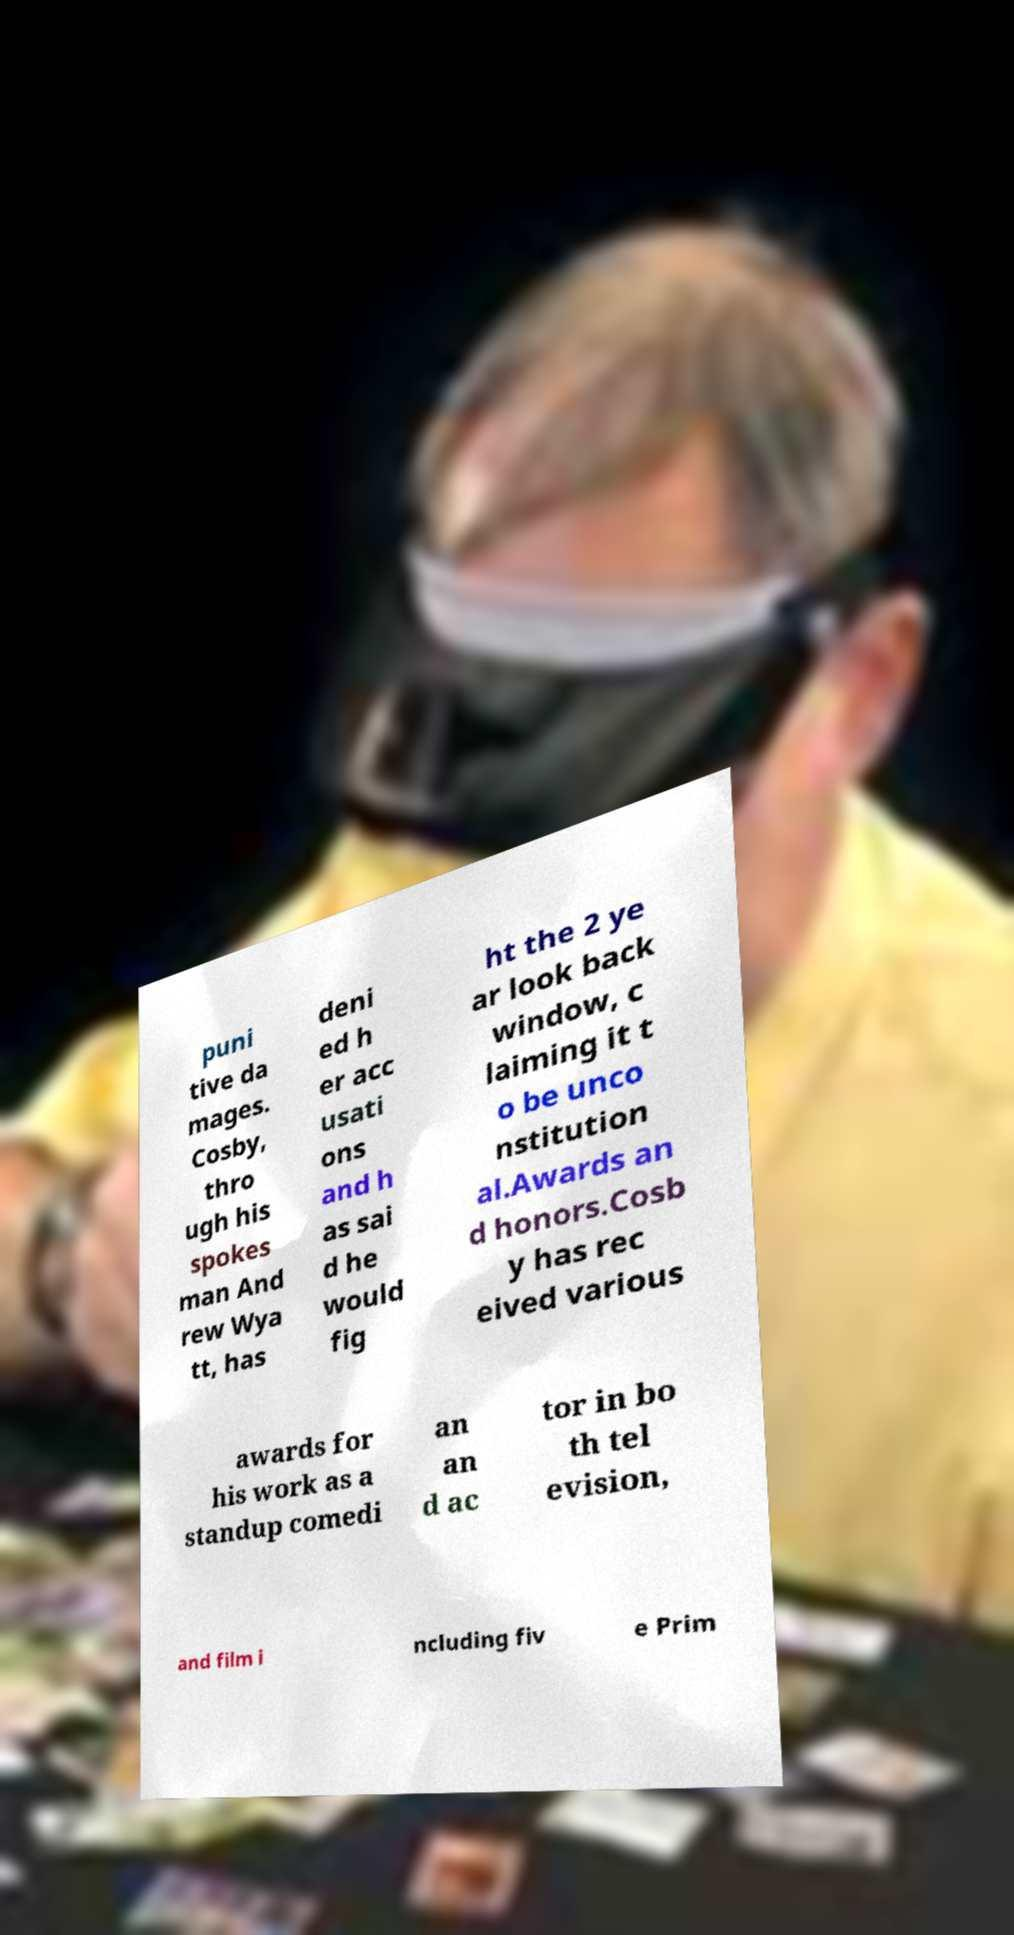Please read and relay the text visible in this image. What does it say? puni tive da mages. Cosby, thro ugh his spokes man And rew Wya tt, has deni ed h er acc usati ons and h as sai d he would fig ht the 2 ye ar look back window, c laiming it t o be unco nstitution al.Awards an d honors.Cosb y has rec eived various awards for his work as a standup comedi an an d ac tor in bo th tel evision, and film i ncluding fiv e Prim 